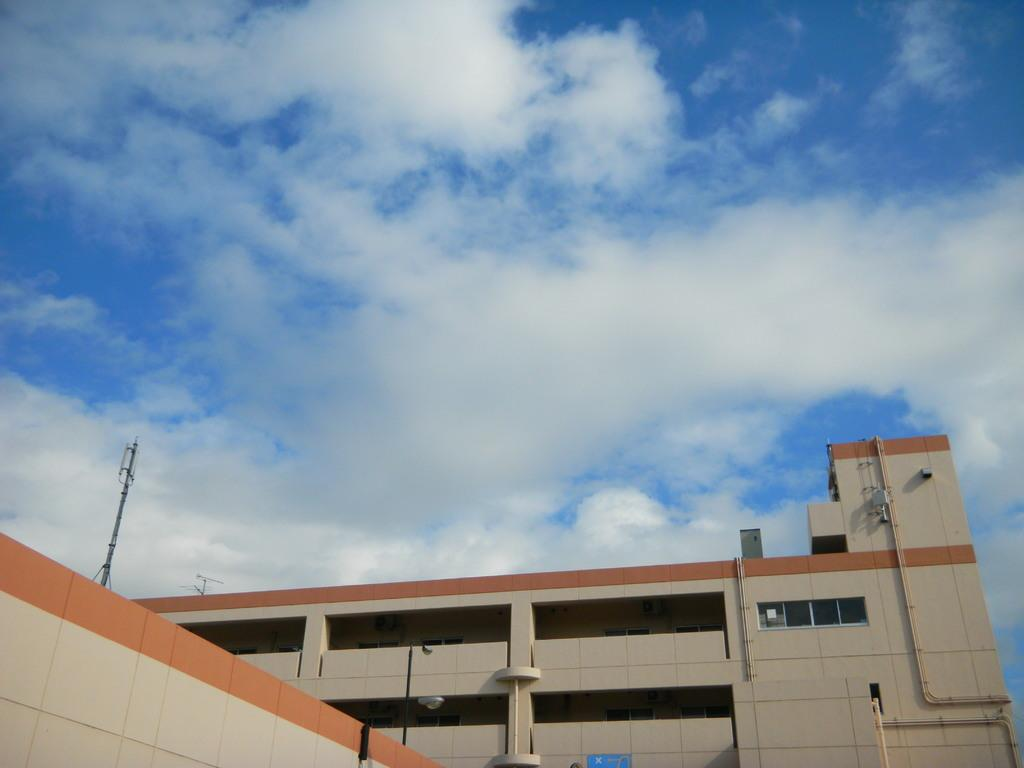What structures are located at the bottom of the image? There are buildings, poles, and pipes at the bottom of the image. What else can be seen at the bottom of the image? There are wires at the bottom of the image. What is visible at the top of the image? The sky is visible at the top of the image. Can you see a squirrel running in a circle around the buildings in the image? There is no squirrel or circular movement present in the image; it features buildings, poles, pipes, wires, and sky. Is there a secretary working at a desk in the image? There is no desk or secretary present in the image. 